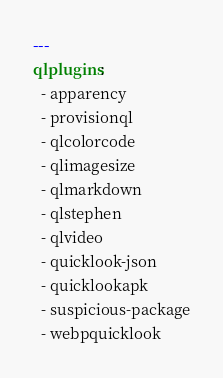Convert code to text. <code><loc_0><loc_0><loc_500><loc_500><_YAML_>---
qlplugins:
  - apparency
  - provisionql
  - qlcolorcode
  - qlimagesize
  - qlmarkdown
  - qlstephen
  - qlvideo
  - quicklook-json
  - quicklookapk
  - suspicious-package
  - webpquicklook
</code> 